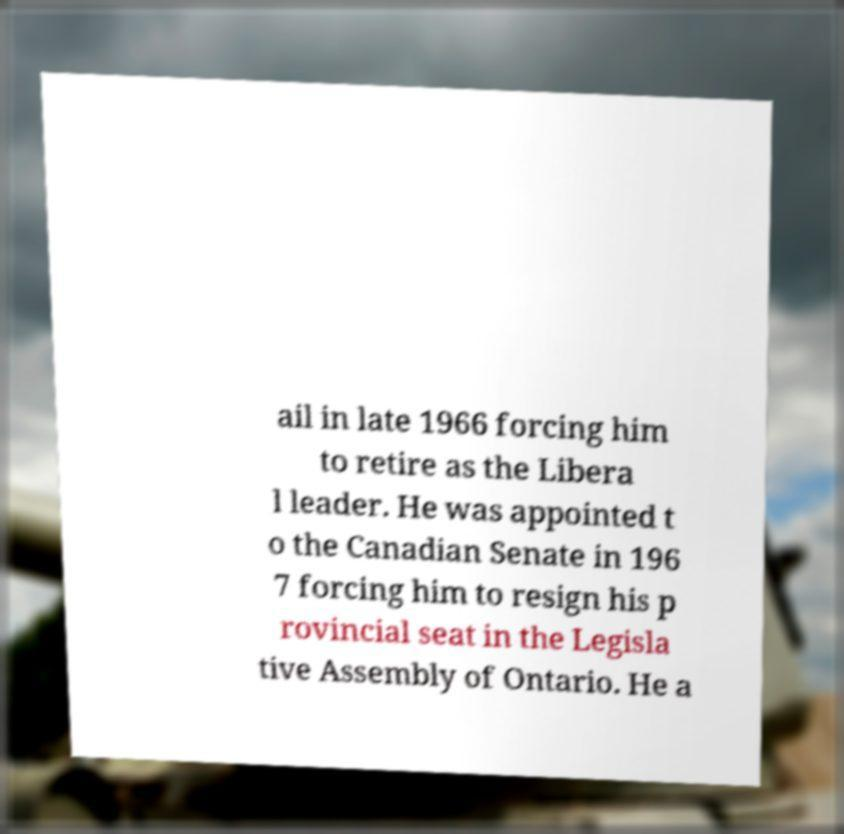Can you accurately transcribe the text from the provided image for me? ail in late 1966 forcing him to retire as the Libera l leader. He was appointed t o the Canadian Senate in 196 7 forcing him to resign his p rovincial seat in the Legisla tive Assembly of Ontario. He a 